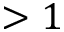Convert formula to latex. <formula><loc_0><loc_0><loc_500><loc_500>> 1</formula> 